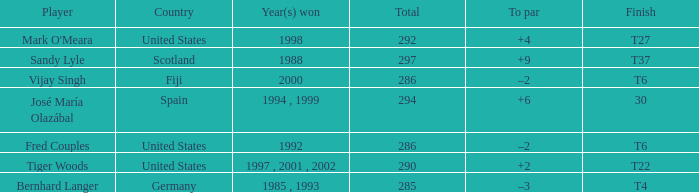Which player has +2 to par? Tiger Woods. 